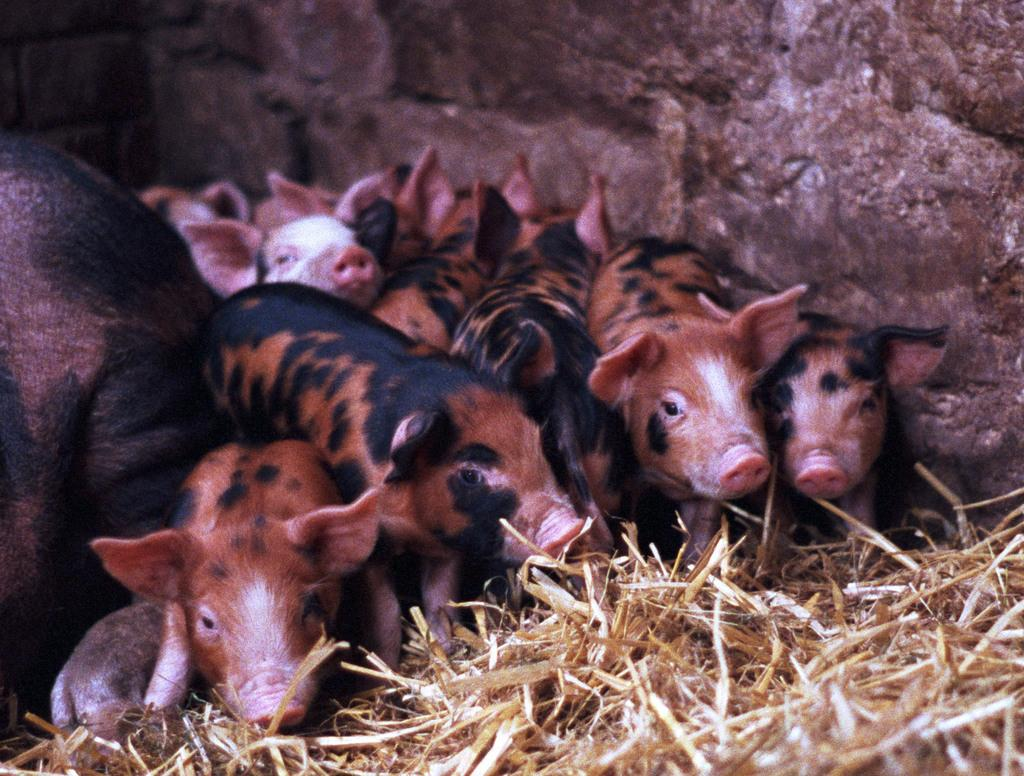What type of animals are in the picture? There are piglets in the picture. What is at the bottom of the picture? Dried grass is present at the bottom of the picture. What can be seen in the background of the picture? There is a stone wall in the background of the picture. What is the weather like in the picture? The provided facts do not mention any information about the weather, so we cannot determine the weather from the image. 